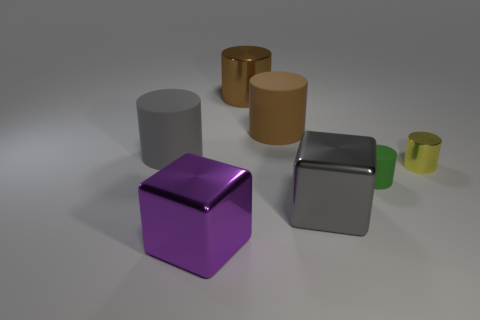There is a rubber thing that is the same color as the big metallic cylinder; what is its shape?
Offer a terse response. Cylinder. The tiny metallic object is what color?
Offer a very short reply. Yellow. Do the big brown metal object that is left of the yellow cylinder and the gray shiny object have the same shape?
Provide a succinct answer. No. What number of objects are either big gray objects that are to the right of the big purple thing or large gray blocks?
Your answer should be very brief. 1. Is there a big yellow object of the same shape as the big brown shiny thing?
Give a very brief answer. No. The brown thing that is the same size as the brown rubber cylinder is what shape?
Give a very brief answer. Cylinder. There is a brown thing that is in front of the metal object that is behind the gray thing left of the large purple block; what shape is it?
Provide a short and direct response. Cylinder. There is a yellow thing; does it have the same shape as the small object that is in front of the small yellow metal thing?
Your answer should be very brief. Yes. What number of large objects are either cyan cylinders or brown matte cylinders?
Offer a terse response. 1. Is there a brown shiny sphere of the same size as the brown rubber cylinder?
Your answer should be compact. No. 